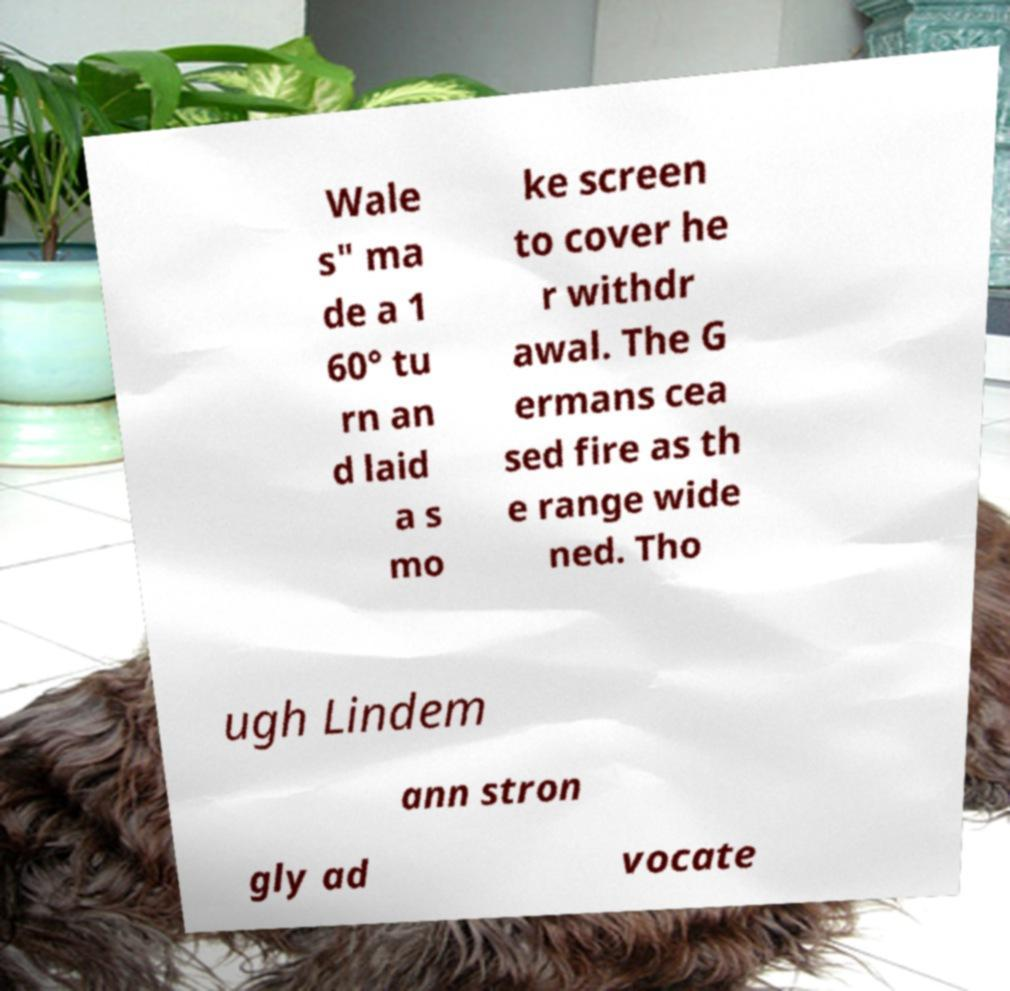Please identify and transcribe the text found in this image. Wale s" ma de a 1 60° tu rn an d laid a s mo ke screen to cover he r withdr awal. The G ermans cea sed fire as th e range wide ned. Tho ugh Lindem ann stron gly ad vocate 